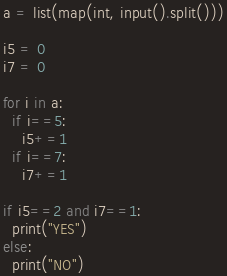<code> <loc_0><loc_0><loc_500><loc_500><_Python_>a = list(map(int, input().split()))

i5 = 0
i7 = 0

for i in a:
  if i==5:
    i5+=1
  if i==7:
    i7+=1

if i5==2 and i7==1:
  print("YES")
else:
  print("NO")
</code> 